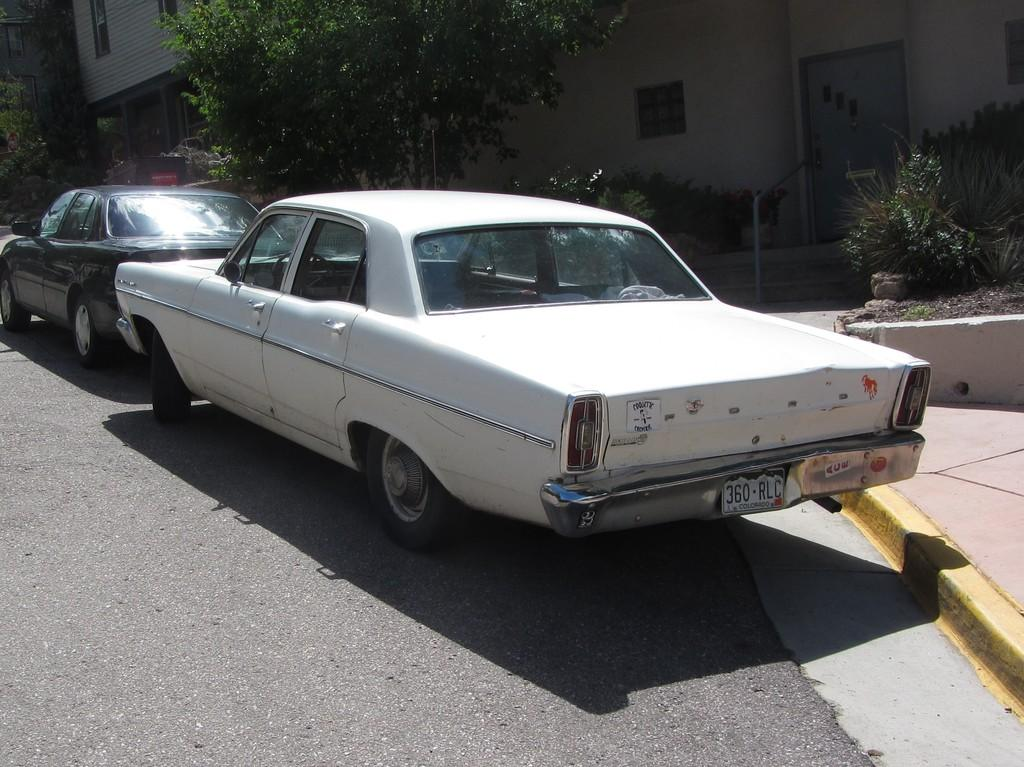What can be seen on the road in the image? There are cars on the road in the image. What type of vegetation is visible in the background of the image? There are plants and trees in the background of the image. What type of structures can be seen in the background of the image? There are buildings in the background of the image. What type of material is present in the background of the image? Metal rods are present in the background of the image. Where is the sofa located in the image? There is no sofa present in the image. What type of cherries are hanging from the metal rods in the image? There are no cherries present in the image; only metal rods are visible in the background. 